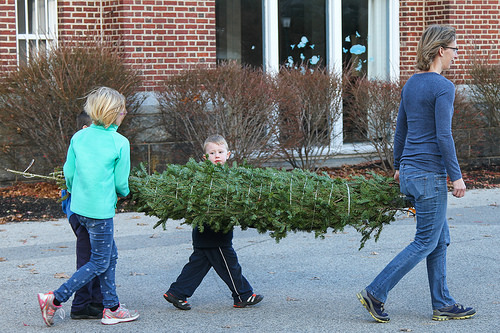<image>
Can you confirm if the boy is to the left of the girl? Yes. From this viewpoint, the boy is positioned to the left side relative to the girl. Is the christmas tree to the left of the woman? Yes. From this viewpoint, the christmas tree is positioned to the left side relative to the woman. 